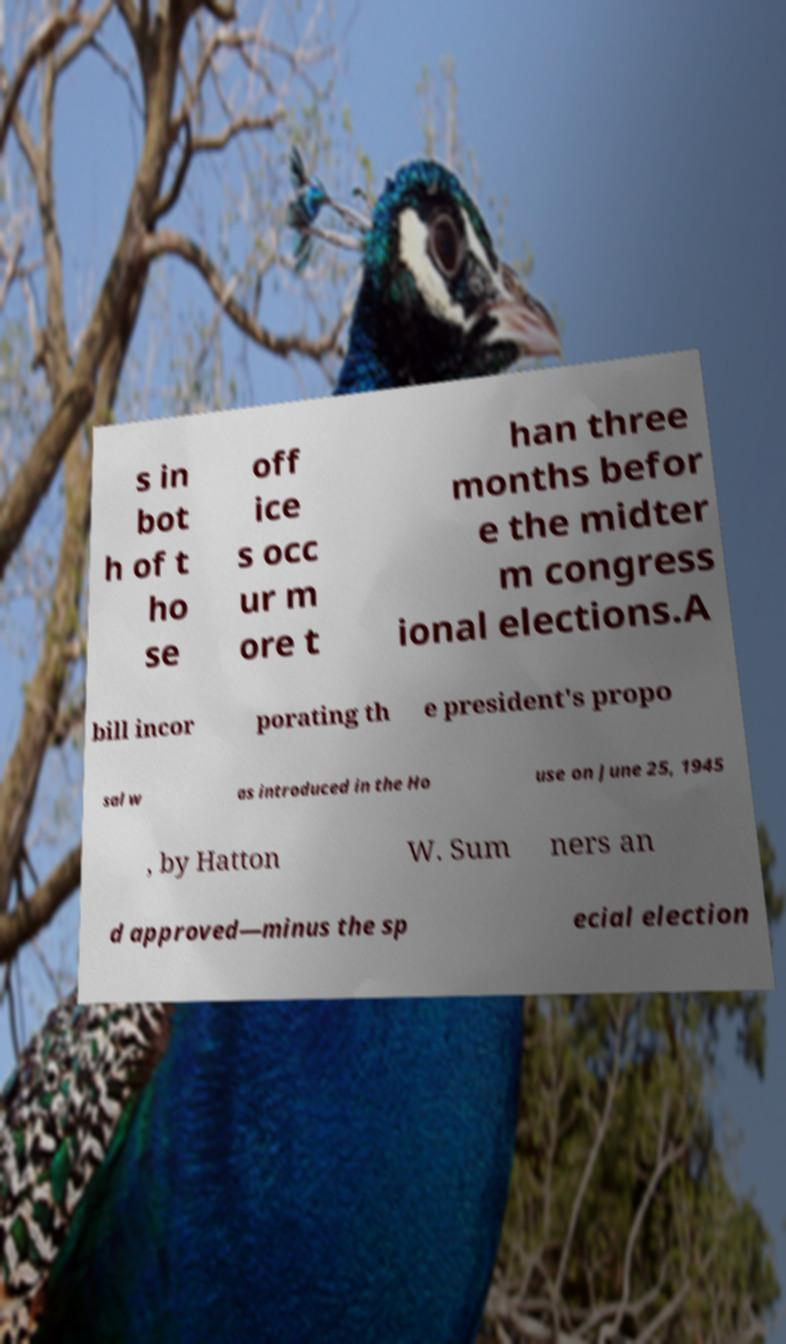I need the written content from this picture converted into text. Can you do that? s in bot h of t ho se off ice s occ ur m ore t han three months befor e the midter m congress ional elections.A bill incor porating th e president's propo sal w as introduced in the Ho use on June 25, 1945 , by Hatton W. Sum ners an d approved—minus the sp ecial election 